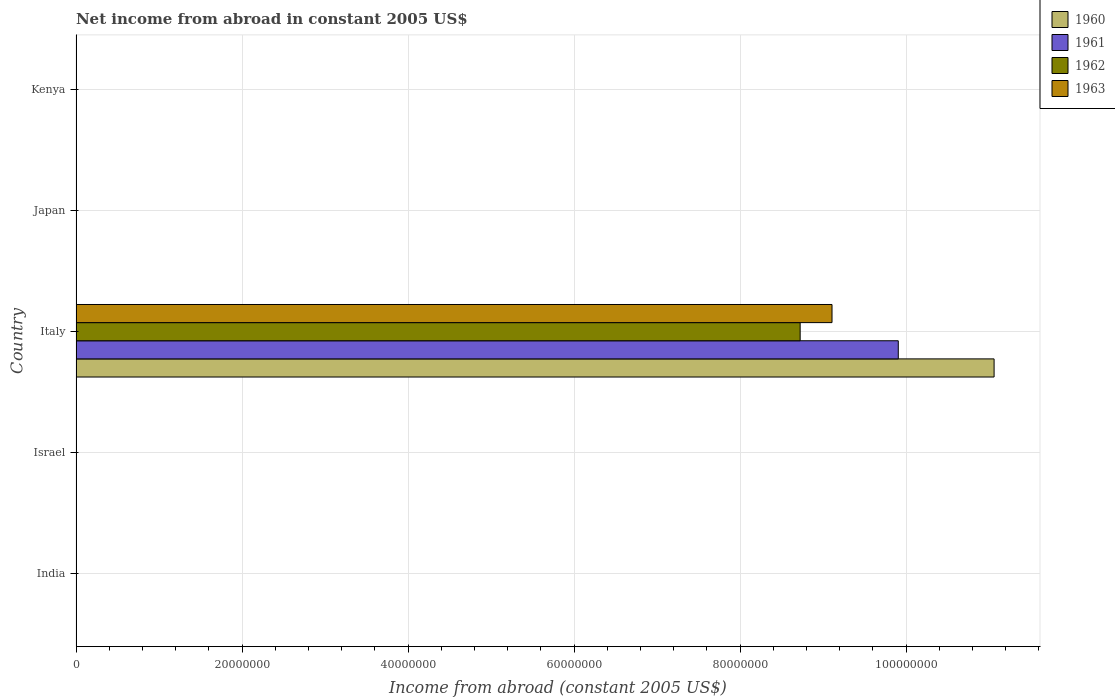How many different coloured bars are there?
Your answer should be very brief. 4. How many bars are there on the 1st tick from the top?
Provide a short and direct response. 0. What is the net income from abroad in 1961 in Israel?
Offer a very short reply. 0. Across all countries, what is the maximum net income from abroad in 1962?
Your response must be concise. 8.72e+07. In which country was the net income from abroad in 1963 maximum?
Your answer should be very brief. Italy. What is the total net income from abroad in 1960 in the graph?
Keep it short and to the point. 1.11e+08. What is the difference between the net income from abroad in 1963 in Japan and the net income from abroad in 1962 in Kenya?
Provide a short and direct response. 0. What is the average net income from abroad in 1960 per country?
Provide a succinct answer. 2.21e+07. What is the difference between the net income from abroad in 1962 and net income from abroad in 1960 in Italy?
Keep it short and to the point. -2.34e+07. In how many countries, is the net income from abroad in 1963 greater than 96000000 US$?
Provide a short and direct response. 0. What is the difference between the highest and the lowest net income from abroad in 1961?
Your response must be concise. 9.91e+07. In how many countries, is the net income from abroad in 1963 greater than the average net income from abroad in 1963 taken over all countries?
Your answer should be compact. 1. Is it the case that in every country, the sum of the net income from abroad in 1961 and net income from abroad in 1962 is greater than the net income from abroad in 1960?
Provide a succinct answer. No. Are all the bars in the graph horizontal?
Provide a short and direct response. Yes. How are the legend labels stacked?
Make the answer very short. Vertical. What is the title of the graph?
Offer a very short reply. Net income from abroad in constant 2005 US$. What is the label or title of the X-axis?
Make the answer very short. Income from abroad (constant 2005 US$). What is the label or title of the Y-axis?
Offer a very short reply. Country. What is the Income from abroad (constant 2005 US$) of 1960 in India?
Your response must be concise. 0. What is the Income from abroad (constant 2005 US$) of 1961 in India?
Your answer should be compact. 0. What is the Income from abroad (constant 2005 US$) in 1963 in India?
Your response must be concise. 0. What is the Income from abroad (constant 2005 US$) in 1961 in Israel?
Your answer should be compact. 0. What is the Income from abroad (constant 2005 US$) in 1962 in Israel?
Provide a short and direct response. 0. What is the Income from abroad (constant 2005 US$) of 1963 in Israel?
Offer a very short reply. 0. What is the Income from abroad (constant 2005 US$) in 1960 in Italy?
Provide a succinct answer. 1.11e+08. What is the Income from abroad (constant 2005 US$) in 1961 in Italy?
Offer a terse response. 9.91e+07. What is the Income from abroad (constant 2005 US$) in 1962 in Italy?
Your answer should be compact. 8.72e+07. What is the Income from abroad (constant 2005 US$) in 1963 in Italy?
Offer a terse response. 9.11e+07. What is the Income from abroad (constant 2005 US$) in 1960 in Japan?
Offer a very short reply. 0. What is the Income from abroad (constant 2005 US$) in 1961 in Japan?
Keep it short and to the point. 0. What is the Income from abroad (constant 2005 US$) of 1961 in Kenya?
Your response must be concise. 0. What is the Income from abroad (constant 2005 US$) of 1963 in Kenya?
Make the answer very short. 0. Across all countries, what is the maximum Income from abroad (constant 2005 US$) in 1960?
Give a very brief answer. 1.11e+08. Across all countries, what is the maximum Income from abroad (constant 2005 US$) in 1961?
Your answer should be very brief. 9.91e+07. Across all countries, what is the maximum Income from abroad (constant 2005 US$) in 1962?
Offer a terse response. 8.72e+07. Across all countries, what is the maximum Income from abroad (constant 2005 US$) of 1963?
Make the answer very short. 9.11e+07. Across all countries, what is the minimum Income from abroad (constant 2005 US$) in 1961?
Give a very brief answer. 0. Across all countries, what is the minimum Income from abroad (constant 2005 US$) in 1963?
Provide a succinct answer. 0. What is the total Income from abroad (constant 2005 US$) of 1960 in the graph?
Your answer should be compact. 1.11e+08. What is the total Income from abroad (constant 2005 US$) in 1961 in the graph?
Ensure brevity in your answer.  9.91e+07. What is the total Income from abroad (constant 2005 US$) of 1962 in the graph?
Ensure brevity in your answer.  8.72e+07. What is the total Income from abroad (constant 2005 US$) of 1963 in the graph?
Ensure brevity in your answer.  9.11e+07. What is the average Income from abroad (constant 2005 US$) in 1960 per country?
Keep it short and to the point. 2.21e+07. What is the average Income from abroad (constant 2005 US$) of 1961 per country?
Ensure brevity in your answer.  1.98e+07. What is the average Income from abroad (constant 2005 US$) in 1962 per country?
Give a very brief answer. 1.74e+07. What is the average Income from abroad (constant 2005 US$) of 1963 per country?
Provide a short and direct response. 1.82e+07. What is the difference between the Income from abroad (constant 2005 US$) in 1960 and Income from abroad (constant 2005 US$) in 1961 in Italy?
Ensure brevity in your answer.  1.15e+07. What is the difference between the Income from abroad (constant 2005 US$) of 1960 and Income from abroad (constant 2005 US$) of 1962 in Italy?
Give a very brief answer. 2.34e+07. What is the difference between the Income from abroad (constant 2005 US$) of 1960 and Income from abroad (constant 2005 US$) of 1963 in Italy?
Keep it short and to the point. 1.95e+07. What is the difference between the Income from abroad (constant 2005 US$) in 1961 and Income from abroad (constant 2005 US$) in 1962 in Italy?
Offer a terse response. 1.18e+07. What is the difference between the Income from abroad (constant 2005 US$) of 1961 and Income from abroad (constant 2005 US$) of 1963 in Italy?
Give a very brief answer. 7.98e+06. What is the difference between the Income from abroad (constant 2005 US$) of 1962 and Income from abroad (constant 2005 US$) of 1963 in Italy?
Ensure brevity in your answer.  -3.84e+06. What is the difference between the highest and the lowest Income from abroad (constant 2005 US$) in 1960?
Offer a terse response. 1.11e+08. What is the difference between the highest and the lowest Income from abroad (constant 2005 US$) of 1961?
Your answer should be very brief. 9.91e+07. What is the difference between the highest and the lowest Income from abroad (constant 2005 US$) of 1962?
Make the answer very short. 8.72e+07. What is the difference between the highest and the lowest Income from abroad (constant 2005 US$) in 1963?
Give a very brief answer. 9.11e+07. 